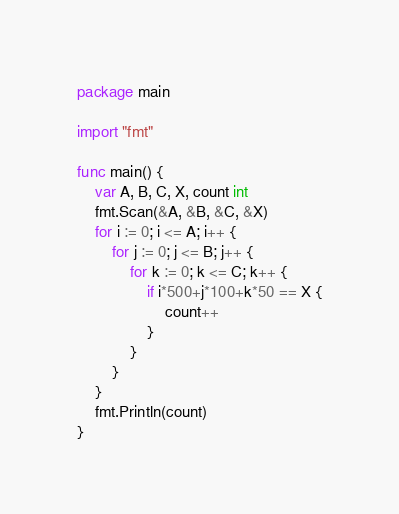Convert code to text. <code><loc_0><loc_0><loc_500><loc_500><_Go_>package main

import "fmt"

func main() {
	var A, B, C, X, count int
	fmt.Scan(&A, &B, &C, &X)
	for i := 0; i <= A; i++ {
		for j := 0; j <= B; j++ {
			for k := 0; k <= C; k++ {
				if i*500+j*100+k*50 == X {
					count++
				}
			}
		}
	}
	fmt.Println(count)
}
</code> 